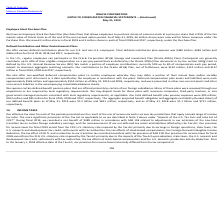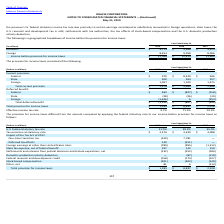According to Oracle Corporation's financial document, Why did the company's provision for income taxes for fiscal 2019 vary from the 21% U.S. statutory rate imposed by the Tax Act? Our provision for income taxes for fiscal 2019 varied from the 21% U.S. statutory rate imposed by the Tax Act primarily due to earnings in foreign operations, state taxes, the U.S. research and development tax credit, settlements with tax authorities, the tax effects of stock-based compensation, the Foreign Derived Intangible Income deduction, the tax effect of GILTI, and a reduction to our transition tax recorded consistent with the provision of SAB 118.. The document states: "ax assets and liabilities affected by the Tax Act. Our provision for income taxes for fiscal 2019 varied from the 21% U.S. statutory rate imposed by t..." Also, Why did the company's provision for income taxes for fiscal 2018 vary from the 21% U.S. statutory rate imposed by the Tax Act? Our provision for income taxes for fiscal 2018 varied from the 21% U.S. statutory rate imposed by the Tax Act primarily due to the impacts of the Tax Act upon adoption, state taxes, the U.S. research and development tax credit, settlements with tax authorities, the tax effects of stock-based compensation and the U.S. domestic production activity deduction.. The document states: "recorded consistent with the provision of SAB 118. Our provision for income taxes for fiscal 2018 varied from the 21% U.S. statutory rate imposed by t..." Also, What was the company's domestic income for fiscal year 2018? According to the financial document, $3,366 (in millions). The relevant text states: "Domestic $ 3,774 $ 3,366 $ 3,674..." Also, can you calculate: What was the average domestic income for the 3 year period from 2017 to 2019? To answer this question, I need to perform calculations using the financial data. The calculation is: (3,774+3,366+3,674)/3, which equals 3604.67 (in millions). This is based on the information: "Domestic $ 3,774 $ 3,366 $ 3,674 Domestic $ 3,774 $ 3,366 $ 3,674 Domestic $ 3,774 $ 3,366 $ 3,674..." The key data points involved are: 3,366, 3,674, 3,774. Also, can you calculate: What was the average total income before provision of income taxes for the 3 year period from 2017 to 2019? To answer this question, I need to perform calculations using the financial data. The calculation is: (12,268+12,424+11,680)/3, which equals 12124 (in millions). This is based on the information: "come before provision for income taxes $ 12,268 $ 12,424 $ 11,680 re provision for income taxes $ 12,268 $ 12,424 $ 11,680 Income before provision for income taxes $ 12,268 $ 12,424 $ 11,680..." The key data points involved are: 11,680, 12,268, 12,424. Also, can you calculate: What is the % change in the foreign income from 2017 to 2018, in billions? To answer this question, I need to perform calculations using the financial data. The calculation is: (9,058-8,006)/8,006, which equals 13.14 (percentage). This is based on the information: "Foreign 8,494 9,058 8,006 Foreign 8,494 9,058 8,006..." The key data points involved are: 8,006, 9,058. 